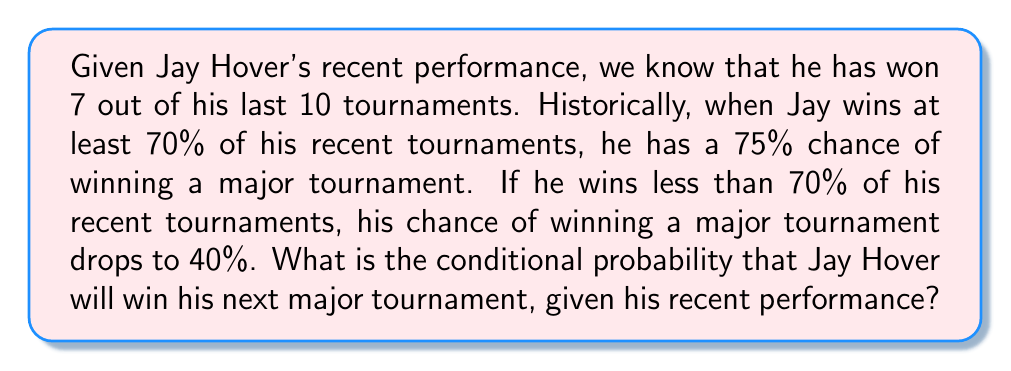Give your solution to this math problem. Let's approach this step-by-step:

1) Let A be the event "Jay wins a major tournament"
   Let B be the event "Jay wins at least 70% of his recent tournaments"

2) We're given:
   $P(A|B) = 0.75$
   $P(A|B^c) = 0.40$
   $P(B) = 1$ (since 7 out of 10 is 70%)

3) We need to find $P(A|B)$, which we already know is 0.75.

4) To double-check using Bayes' theorem:

   $$P(A|B) = \frac{P(B|A)P(A)}{P(B)}$$

   But we don't need to use this as we're directly given $P(A|B)$.

5) Therefore, the conditional probability that Jay Hover will win his next major tournament, given his recent performance of winning 7 out of 10 tournaments, is 0.75 or 75%.
Answer: 0.75 